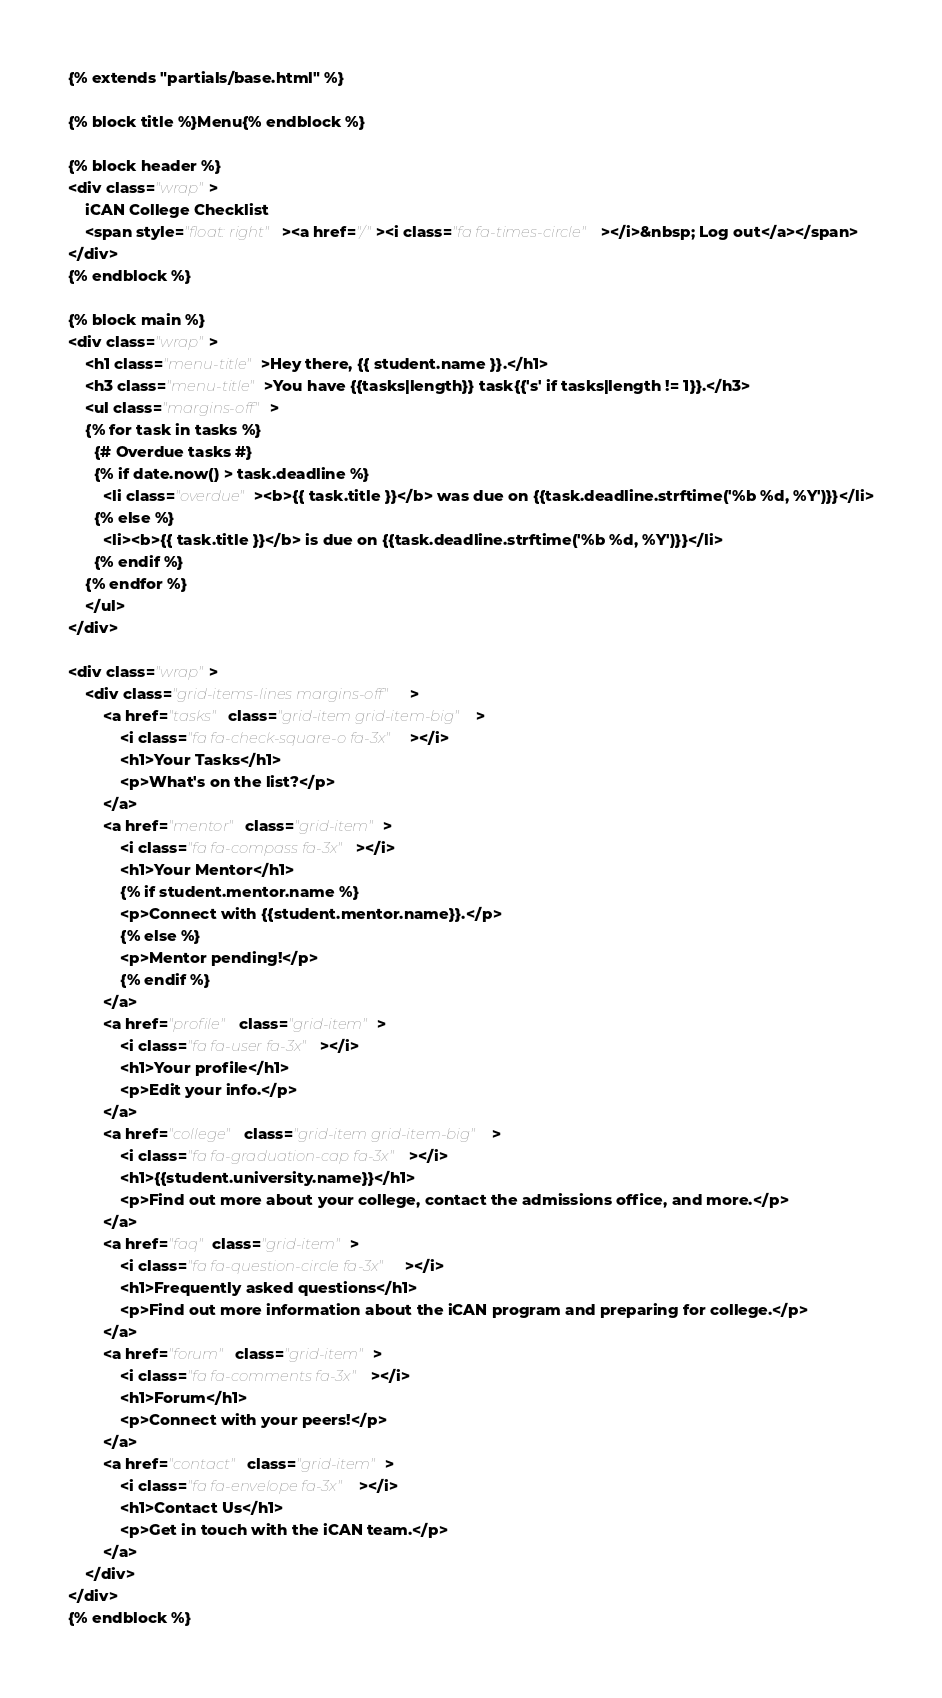<code> <loc_0><loc_0><loc_500><loc_500><_HTML_>{% extends "partials/base.html" %}

{% block title %}Menu{% endblock %}

{% block header %}
<div class="wrap">
    iCAN College Checklist
    <span style="float: right"><a href="/"><i class="fa fa-times-circle"></i>&nbsp; Log out</a></span>
</div>
{% endblock %}

{% block main %}
<div class="wrap">
    <h1 class="menu-title">Hey there, {{ student.name }}.</h1>
    <h3 class="menu-title">You have {{tasks|length}} task{{'s' if tasks|length != 1}}.</h3>
    <ul class="margins-off">
    {% for task in tasks %}
      {# Overdue tasks #}
      {% if date.now() > task.deadline %}
        <li class="overdue"><b>{{ task.title }}</b> was due on {{task.deadline.strftime('%b %d, %Y')}}</li>
      {% else %}
        <li><b>{{ task.title }}</b> is due on {{task.deadline.strftime('%b %d, %Y')}}</li>
      {% endif %}
    {% endfor %}
    </ul>
</div>

<div class="wrap">
    <div class="grid-items-lines margins-off">
        <a href="tasks" class="grid-item grid-item-big">
            <i class="fa fa-check-square-o fa-3x"></i>
            <h1>Your Tasks</h1>
            <p>What's on the list?</p>
        </a>
        <a href="mentor" class="grid-item">
            <i class="fa fa-compass fa-3x"></i>
            <h1>Your Mentor</h1>
            {% if student.mentor.name %}
            <p>Connect with {{student.mentor.name}}.</p>
            {% else %}
            <p>Mentor pending!</p>
            {% endif %}
        </a>
        <a href="profile" class="grid-item">
            <i class="fa fa-user fa-3x"></i>
            <h1>Your profile</h1>
            <p>Edit your info.</p>
        </a>
        <a href="college" class="grid-item grid-item-big">
            <i class="fa fa-graduation-cap fa-3x"></i>
            <h1>{{student.university.name}}</h1>
            <p>Find out more about your college, contact the admissions office, and more.</p>
        </a>
        <a href="faq" class="grid-item">
            <i class="fa fa-question-circle fa-3x"></i>
            <h1>Frequently asked questions</h1>
            <p>Find out more information about the iCAN program and preparing for college.</p>
        </a>
        <a href="forum" class="grid-item">
            <i class="fa fa-comments fa-3x"></i>
            <h1>Forum</h1>
            <p>Connect with your peers!</p>
        </a>
        <a href="contact" class="grid-item">
            <i class="fa fa-envelope fa-3x"></i>
            <h1>Contact Us</h1>
            <p>Get in touch with the iCAN team.</p>
        </a>
    </div>
</div>
{% endblock %}
</code> 